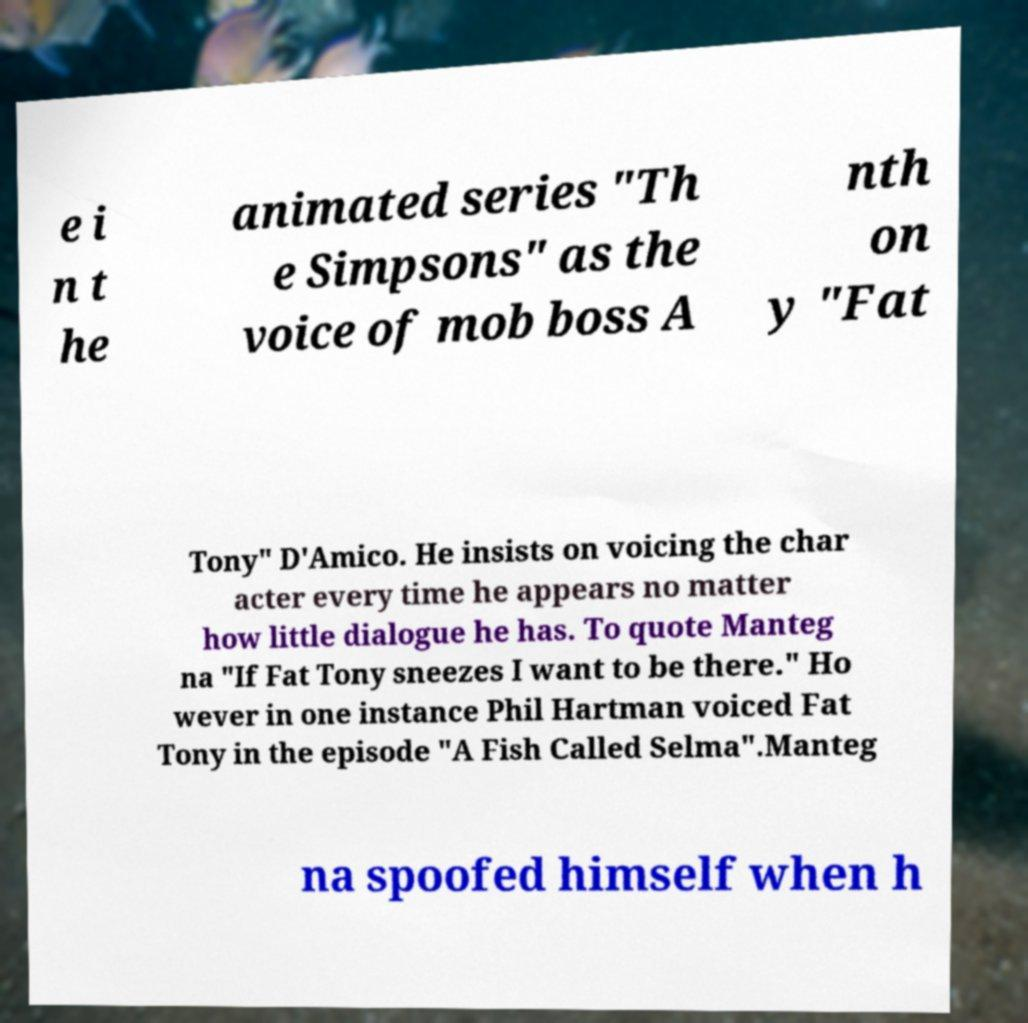What messages or text are displayed in this image? I need them in a readable, typed format. e i n t he animated series "Th e Simpsons" as the voice of mob boss A nth on y "Fat Tony" D'Amico. He insists on voicing the char acter every time he appears no matter how little dialogue he has. To quote Manteg na "If Fat Tony sneezes I want to be there." Ho wever in one instance Phil Hartman voiced Fat Tony in the episode "A Fish Called Selma".Manteg na spoofed himself when h 